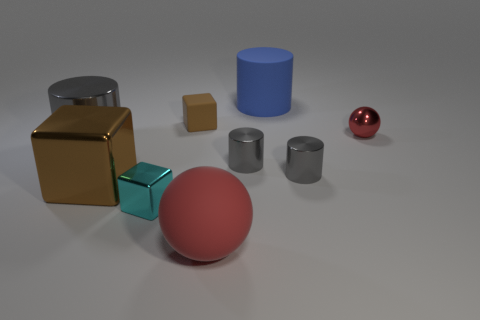Subtract all brown shiny cubes. How many cubes are left? 2 Add 1 tiny green cylinders. How many objects exist? 10 Subtract all gray cylinders. How many cylinders are left? 1 Subtract all spheres. How many objects are left? 7 Subtract all cyan balls. How many brown cubes are left? 2 Subtract 2 cylinders. How many cylinders are left? 2 Subtract all brown cylinders. Subtract all blue spheres. How many cylinders are left? 4 Subtract all large purple cylinders. Subtract all gray metal cylinders. How many objects are left? 6 Add 6 tiny red things. How many tiny red things are left? 7 Add 1 big red things. How many big red things exist? 2 